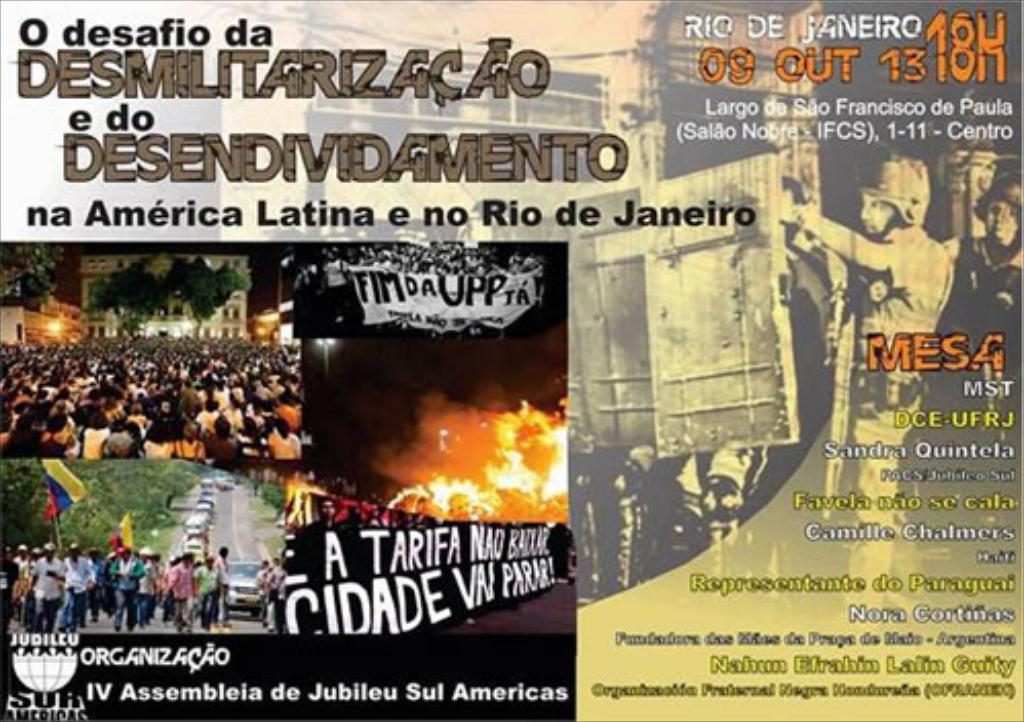Provide a one-sentence caption for the provided image. The image depicts a provocative poster that seems related to political and social activism in Latin America and Rio de Janeiro, featuring crowded protests, a call for an end to militarization and indebtedness, and references to various social organizations and leaders. 